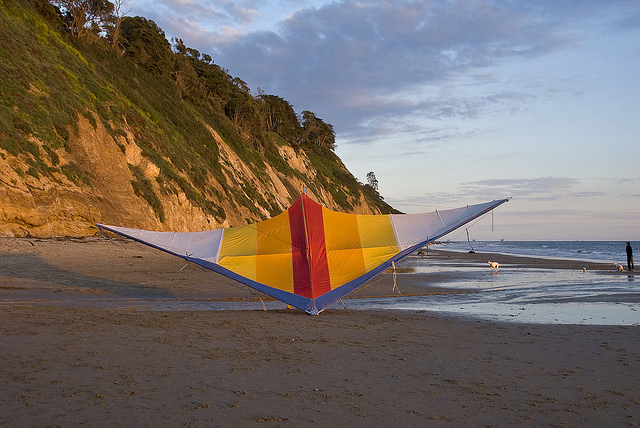What kind of day does the image suggest it is? The image suggests a pleasant day, likely in the late afternoon or early evening. The sky has a mix of clouds and a warm, golden hue, implying that the sun is either setting or just past its peak. The light and shade across the cliffs and beach create a tranquil and inviting atmosphere. How do the natural elements in the image contribute to the overall scene? The natural elements play a significant role in enhancing the overall scene. The cliffs provide a dramatic backdrop, covered with lush greenery that contrasts beautifully with the warm colors of the kite. The sand adds a smooth, inviting surface that stretches toward the ocean, whose gentle waves add movement and life to the picture. The sky, with its mix of soft clouds and golden light, casts a serene glow over the entire setting, creating a harmonious and picturesque landscape. 